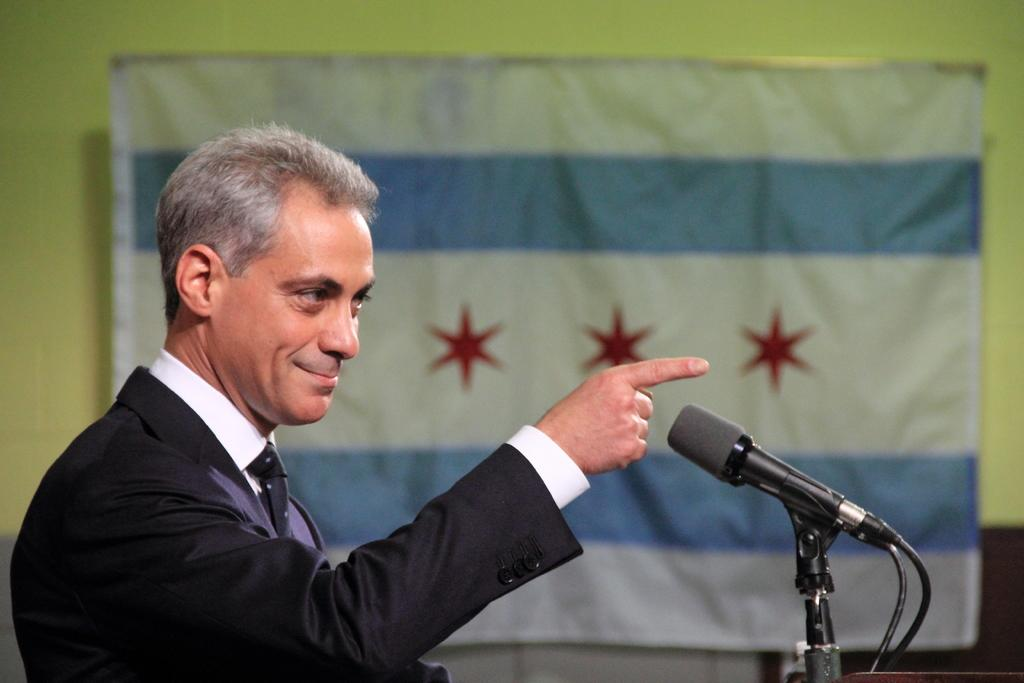What is the main subject of the image? The main subject of the image is a man. What is the man doing in the image? The man is standing in front of a mic and pointing his hand towards something. What can be seen behind the man? There is a banner behind the man. What type of land can be seen in the image? There is no land visible in the image; it features a man standing in front of a mic with a banner behind him. How is the man using glue in the image? There is no glue present in the image, and the man is not using any glue. 